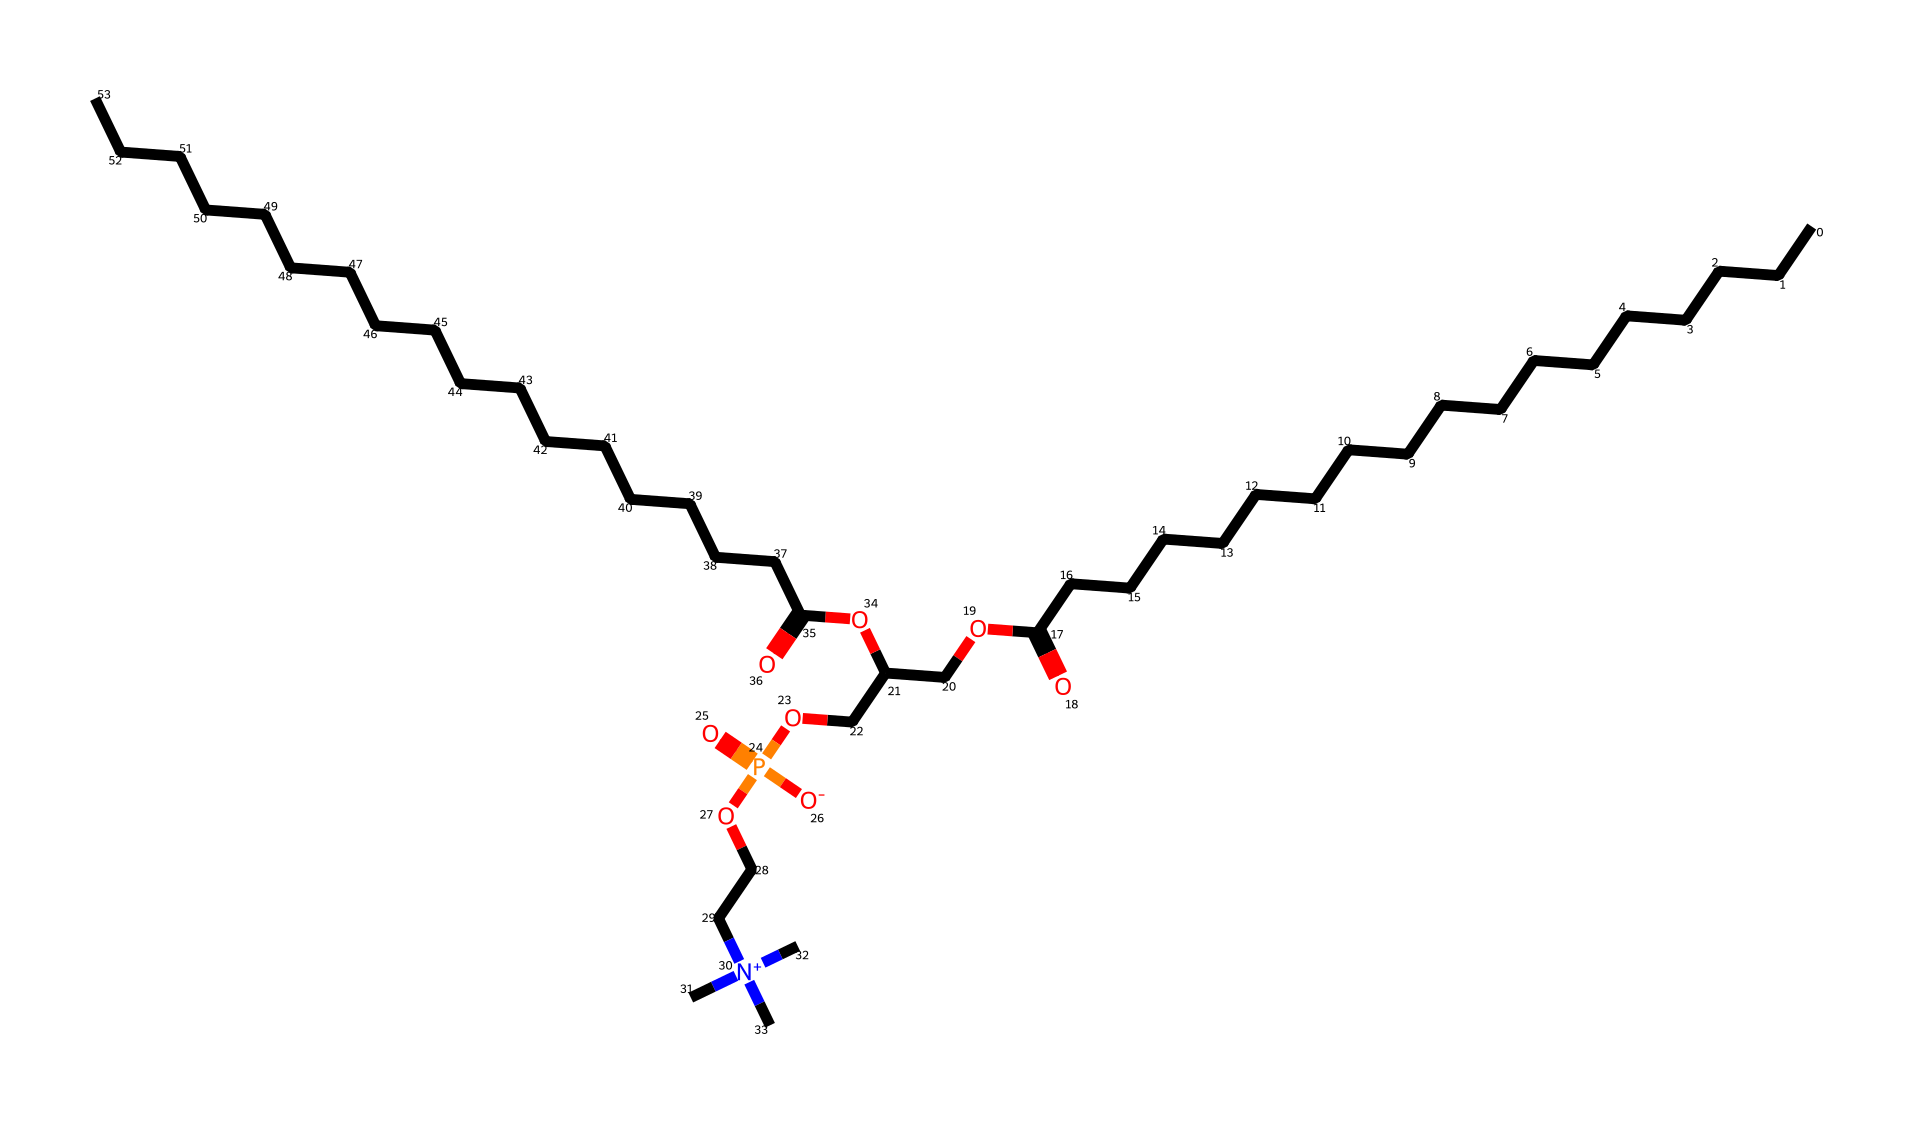How many carbon atoms are in the structure? The structure represented by the SMILES contains long carbon chains. By counting, there are 34 carbon atoms total in both the fatty acid chains and the linking groups.
Answer: 34 What functional group is present that indicates this molecule is a phospholipid? A phospholipid is characterized by the presence of a phosphate group, which can be discerned from the segment "P(=O)([O-])" in the structure, indicating phosphate.
Answer: phosphate How many ester linkages are in the molecule? The presence of ester linkages can be identified by looking for carbonyl (C=O) groups followed by oxygen atoms (O). Tracing through the structure, two ester linkages can be identified.
Answer: 2 What property does the presence of the charged nitrogen atom impart to this phospholipid? The charged nitrogen ([N+](C)(C)C) contributes to the hydrophilicity of the molecule, making it more polar and capable of interacting with water, which is essential for its function in biological membranes and in sunscreens.
Answer: hydrophilicity Which part of the molecule contains the hydrophobic tails? The long carbon chains (CCCCCCCCCCCCCCCCCC and CCCCCCCCCCCCCCCCCCC) connected to the phosphate group represent the hydrophobic tails of the phospholipid, designed to repel water and provide structure in a bilayer arrangement.
Answer: hydrophobic tails How does this structure relate to its function in sunscreen? The amphiphilic nature of this phospholipid (having both hydrophilic and hydrophobic parts) allows it to form stable emulsions, trapping UV filters in a water-repellent environment, which helps protect against sun damage effectively.
Answer: emulsions 